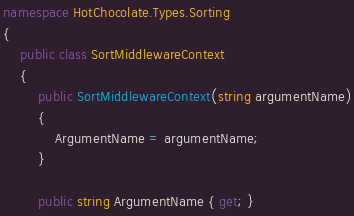<code> <loc_0><loc_0><loc_500><loc_500><_C#_>namespace HotChocolate.Types.Sorting
{
    public class SortMiddlewareContext
    {
        public SortMiddlewareContext(string argumentName)
        {
            ArgumentName = argumentName;
        }

        public string ArgumentName { get; }
</code> 